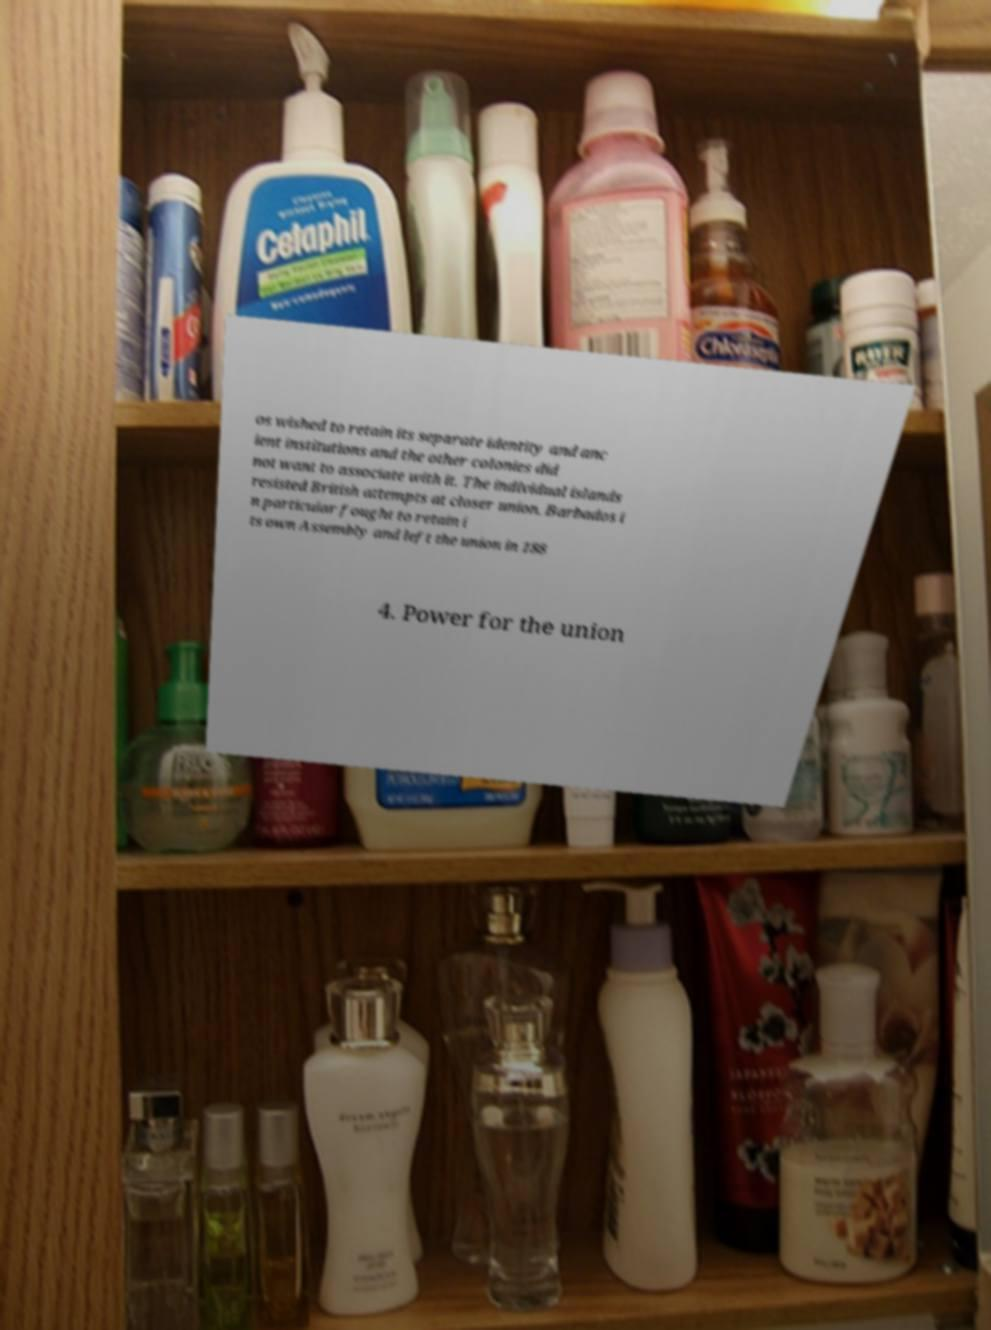I need the written content from this picture converted into text. Can you do that? os wished to retain its separate identity and anc ient institutions and the other colonies did not want to associate with it. The individual islands resisted British attempts at closer union. Barbados i n particular fought to retain i ts own Assembly and left the union in 188 4. Power for the union 